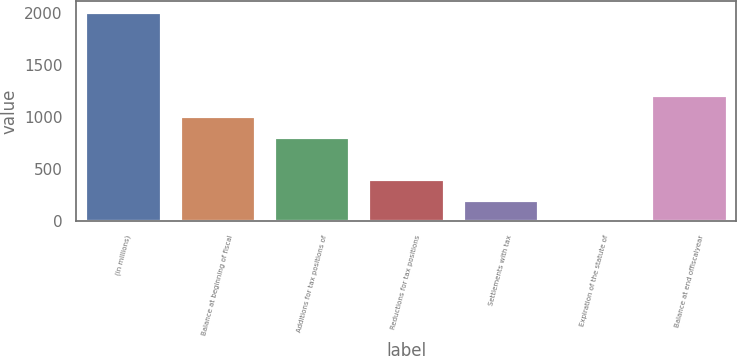Convert chart. <chart><loc_0><loc_0><loc_500><loc_500><bar_chart><fcel>(in millions)<fcel>Balance at beginning of fiscal<fcel>Additions for tax positions of<fcel>Reductions for tax positions<fcel>Settlements with tax<fcel>Expiration of the statute of<fcel>Balance at end offiscalyear<nl><fcel>2009<fcel>1007.1<fcel>806.72<fcel>405.96<fcel>205.58<fcel>5.2<fcel>1207.48<nl></chart> 